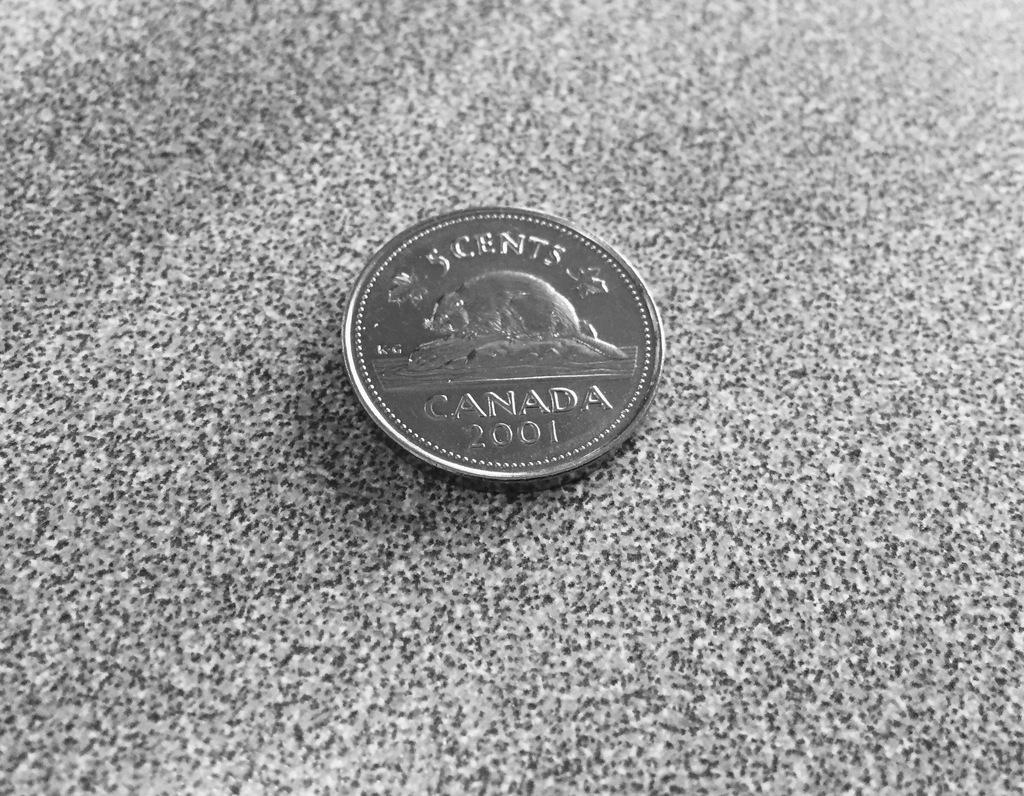<image>
Summarize the visual content of the image. The 5 cent coin from Canada is from 2001. 